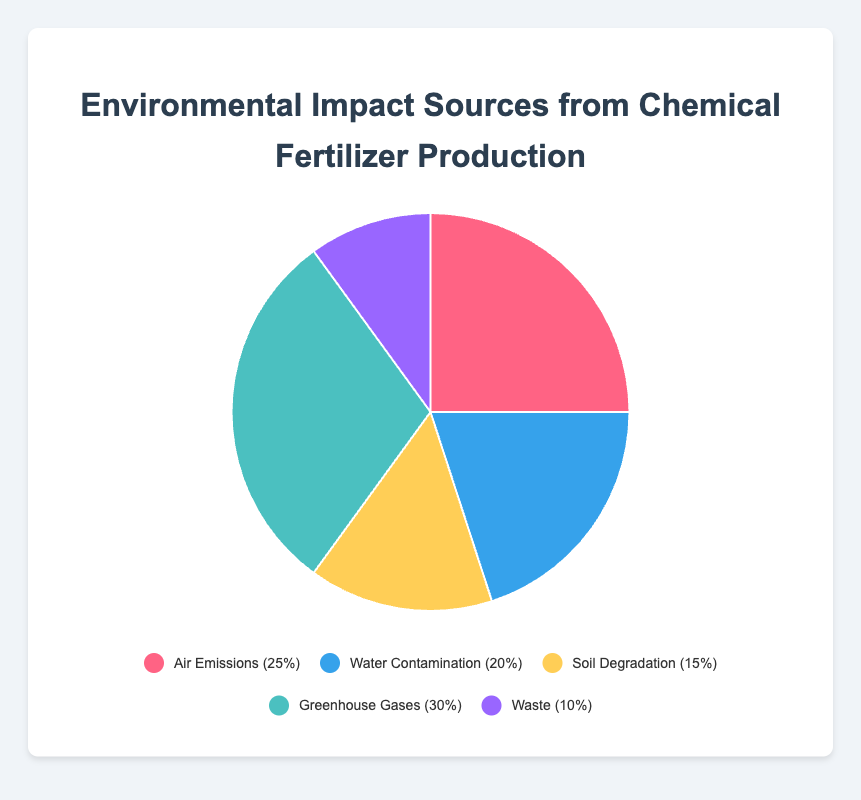what is the sum of percentages for Air Emissions, Water Contamination, and Soil Degradation? Add the percentages for Air Emissions (25%), Water Contamination (20%), and Soil Degradation (15%): 25 + 20 + 15 = 60.
Answer: 60% Which source contributes the most to environmental impact? The source with the highest percentage in the pie chart is Greenhouse Gases (30%).
Answer: Greenhouse Gases Which two sources combined account for 40% of the environmental impact? Identify two sources whose combined percentages equal 40%. Air Emissions (25%) and either Waste (10%) or Soil Degradation (15%) don’t add up to 40%. Water Contamination (20%) and Soil Degradation (15%) add to 35%. Greenhouse Gases (30%) and Waste (10%) add to 40%.
Answer: Greenhouse Gases and Waste How much more does Greenhouse Gases contribute compared to Soil Degradation? Subtract the percentage for Soil Degradation (15%) from Greenhouse Gases (30%): 30 - 15 = 15.
Answer: 15% Which source accounts for the smallest percentage of the environmental impact? The source with the smallest percentage in the pie chart is Waste (10%).
Answer: Waste What percentage of the environmental impact is not due to Greenhouse Gases? Subtract the percentage of Greenhouse Gases (30%) from the total (100%): 100 - 30 = 70.
Answer: 70% What is the average percentage of the five environmental impact sources? Add the percentages of all sources: 25 + 20 + 15 + 30 + 10 = 100. Divide by the number of sources: 100 / 5 = 20.
Answer: 20% Which source has the closest impact percentage to Air Emissions? Air Emissions is 25%. The other percentages are 20%, 15%, 30%, and 10%. Water Contamination, at 20%, is the closest to 25%.
Answer: Water Contamination 